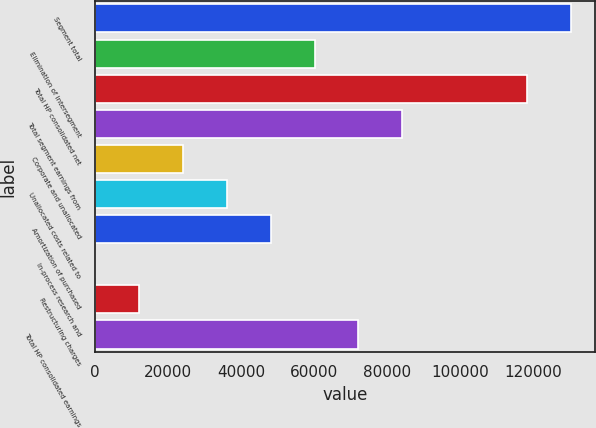Convert chart to OTSL. <chart><loc_0><loc_0><loc_500><loc_500><bar_chart><fcel>Segment total<fcel>Elimination of intersegment<fcel>Total HP consolidated net<fcel>Total segment earnings from<fcel>Corporate and unallocated<fcel>Unallocated costs related to<fcel>Amortization of purchased<fcel>In-process research and<fcel>Restructuring charges<fcel>Total HP consolidated earnings<nl><fcel>130376<fcel>60107<fcel>118364<fcel>84131.8<fcel>24069.8<fcel>36082.2<fcel>48094.6<fcel>45<fcel>12057.4<fcel>72119.4<nl></chart> 